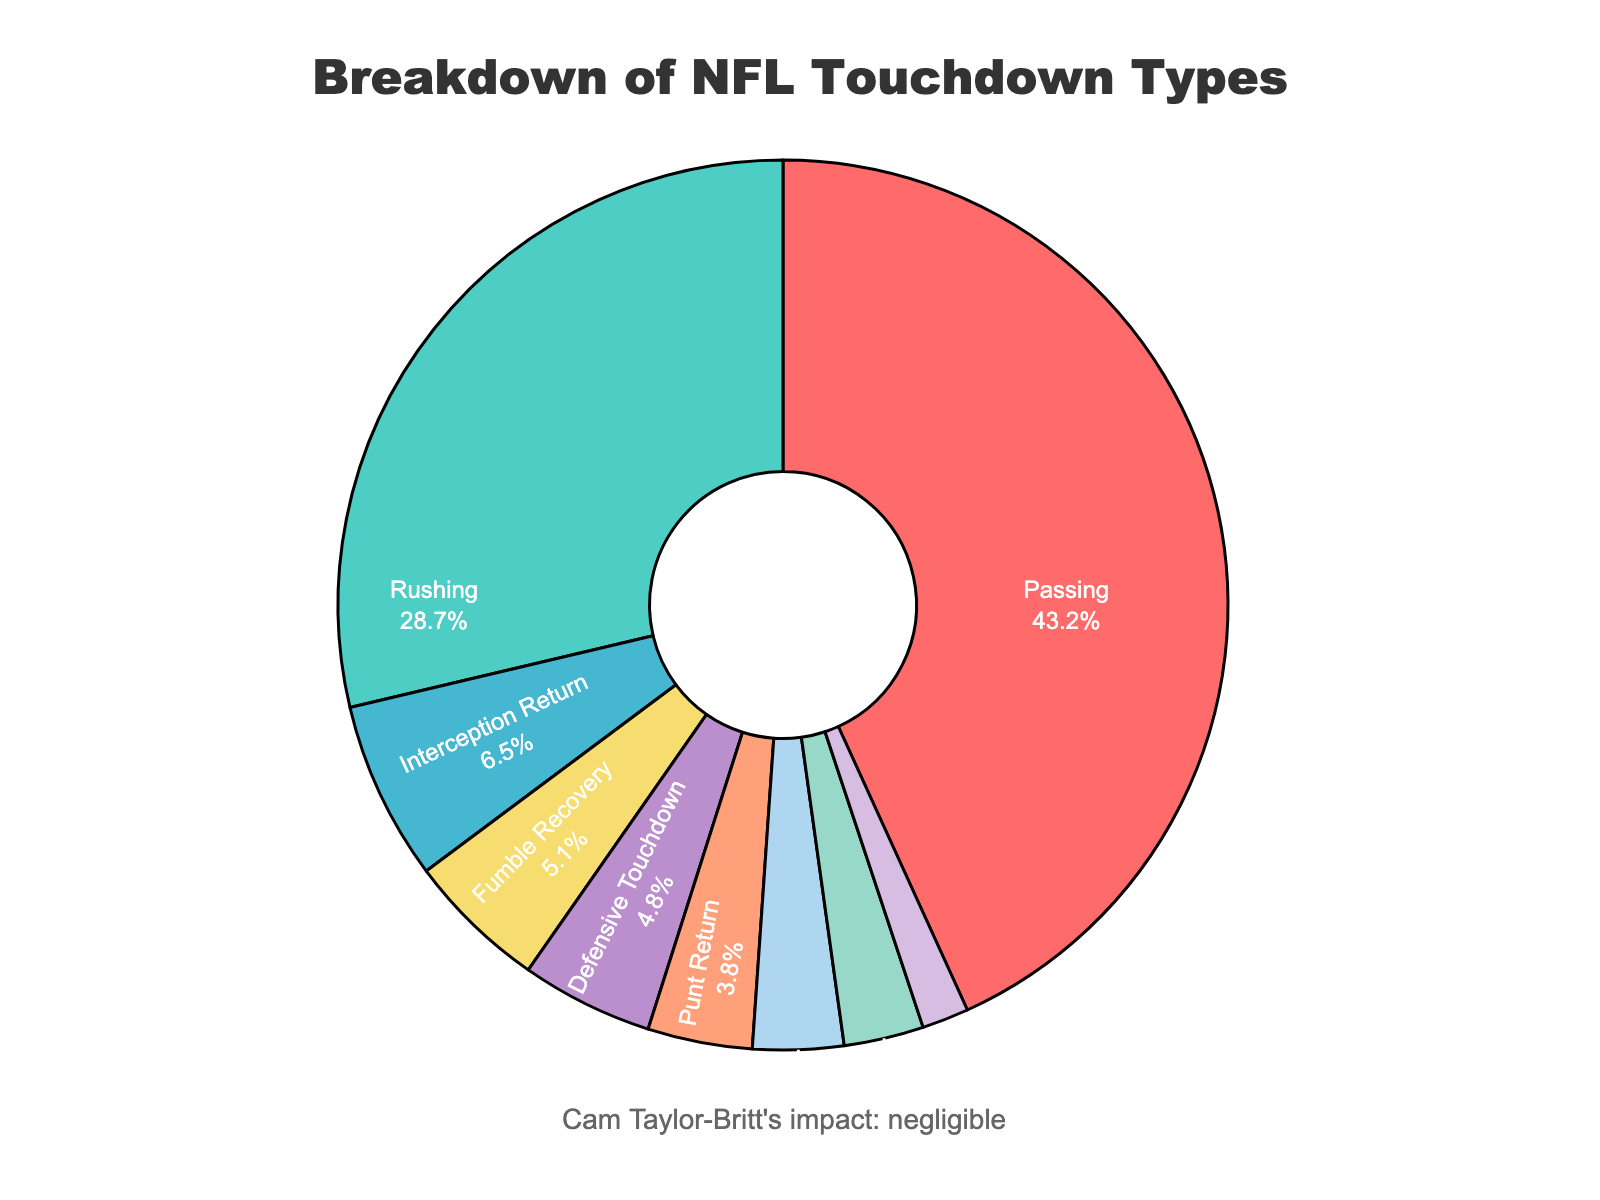What type of touchdown is the least common according to the chart? The chart shows a pie segment for each type of touchdown. The smallest segment corresponds to "Special Teams (Non-Return)" touchdowns.
Answer: Special Teams (Non-Return) What's the combined percentage of all types of return touchdowns (Punt, Kickoff, Interception)? Add the percentages for Punt Return (3.8%), Kickoff Return (2.9%), and Interception Return (6.5%). 3.8 + 2.9 + 6.5 = 13.2%
Answer: 13.2% What is the percentage difference between passing and rushing touchdowns? Refer to the chart to find 'Passing' at 43.2% and 'Rushing' at 28.7%. Subtract the two values: 43.2 - 28.7 = 14.5%
Answer: 14.5% How does the percentage of Defensive Touchdowns compare to Fumble Recovery touchdowns? Defensive Touchdowns are 4.8% and Fumble Recovery touchdowns are 5.1%. Compare the two values to see that Fumble Recovery touchdowns have a slightly higher percentage than Defensive Touchdowns.
Answer: Fumble Recovery is higher Which touchdown type represents the largest segment in the pie chart? The pie chart’s largest segment corresponds to 'Passing' touchdowns, which is the segment with the highest percentage, 43.2%.
Answer: Passing By how much does the sum of Defensive Touchdowns and Fumble Recovery touchdowns exceed the percentage of Two-Point Conversions? First, sum the percentages for Defensive Touchdowns (4.8%) and Fumble Recovery (5.1%): 4.8 + 5.1 = 9.9%. Then subtract the Two-Point Conversions' percentage (3.3%): 9.9 - 3.3 = 6.6%.
Answer: 6.6% Which two touchdown types have the closest percentages? Compare the percentages of each segment. Defensive Touchdowns (4.8%) and Fumble Recovery touchdowns (5.1%) have values that are closest.
Answer: Defensive Touchdowns and Fumble Recovery What is the combined percentage of non-offensive touchdowns (Interception Return, Punt Return, Kickoff Return, Fumble Recovery, Defensive Touchdown, Special Teams Non-Return)? Add the percentages for all non-offensive touchdown types: 6.5 + 3.8 + 2.9 + 5.1 + 4.8 + 1.7 = 24.8%.
Answer: 24.8% How does the total percentage of all return touchdowns compare to that of passing touchdowns? Calculate sum of all return touchdowns: Interception Return (6.5%) + Punt Return (3.8%) + Kickoff Return (2.9%) = 13.2%. Now compare 13.2% to Passing touchdowns (43.2%): Passing touchdowns exceed return touchdowns by 43.2 - 13.2 = 30%.
Answer: 30% 